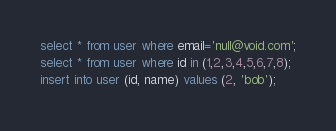Convert code to text. <code><loc_0><loc_0><loc_500><loc_500><_SQL_>select * from user where email='null@void.com';
select * from user where id in (1,2,3,4,5,6,7,8);
insert into user (id, name) values (2, 'bob');
</code> 